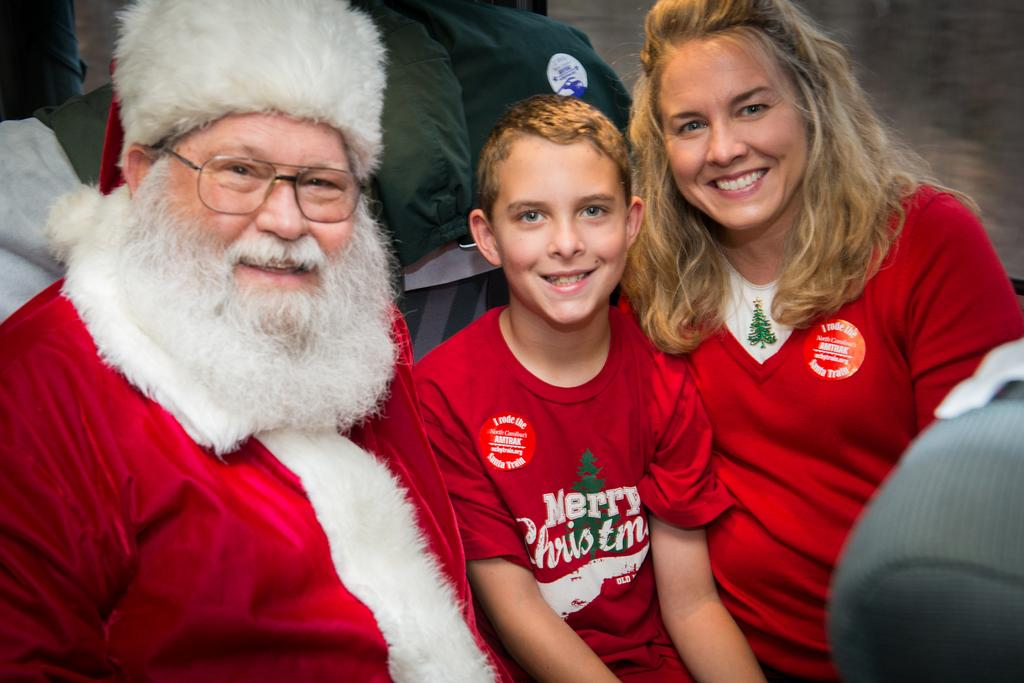<image>
Offer a succinct explanation of the picture presented. A woman and child wearing red shirts with Merry Christmas on the child's shirt sitting with Santa. 